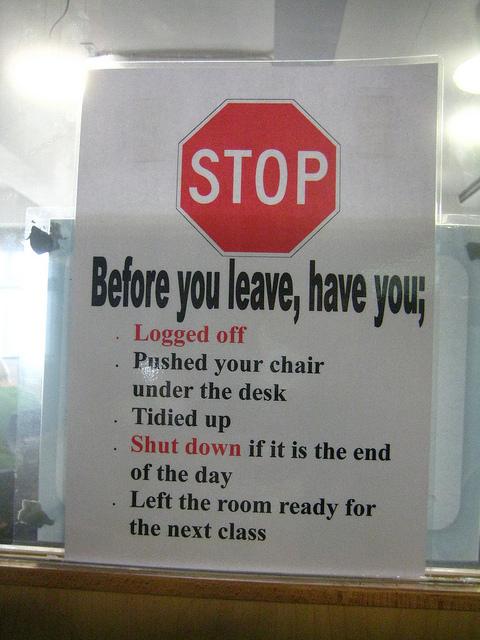What shape is the sign?
Be succinct. Rectangle. Is there a red stop sign on the window?
Be succinct. Yes. What are people supposed to do before they leave?
Quick response, please. Log off and shut down. 